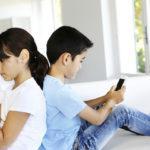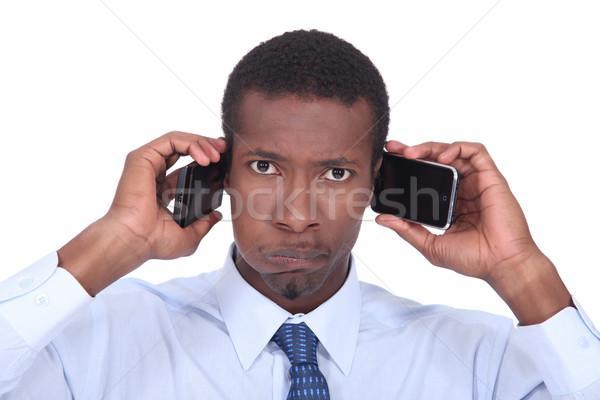The first image is the image on the left, the second image is the image on the right. Considering the images on both sides, is "In the image to the left, a person is holding a phone; the phone is not up to anyone's ear." valid? Answer yes or no. Yes. The first image is the image on the left, the second image is the image on the right. Evaluate the accuracy of this statement regarding the images: "Only one person is holding a phone to their ear.". Is it true? Answer yes or no. Yes. 